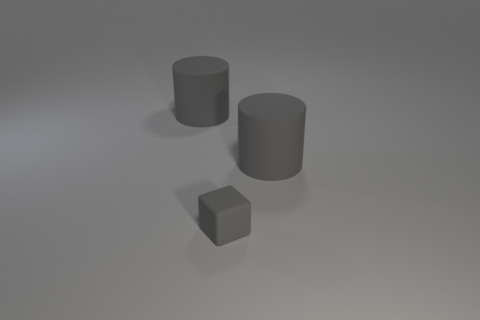Add 2 small things. How many objects exist? 5 Subtract all cylinders. How many objects are left? 1 Subtract all tiny yellow rubber cylinders. Subtract all large rubber cylinders. How many objects are left? 1 Add 3 large gray rubber things. How many large gray rubber things are left? 5 Add 3 rubber objects. How many rubber objects exist? 6 Subtract 1 gray cylinders. How many objects are left? 2 